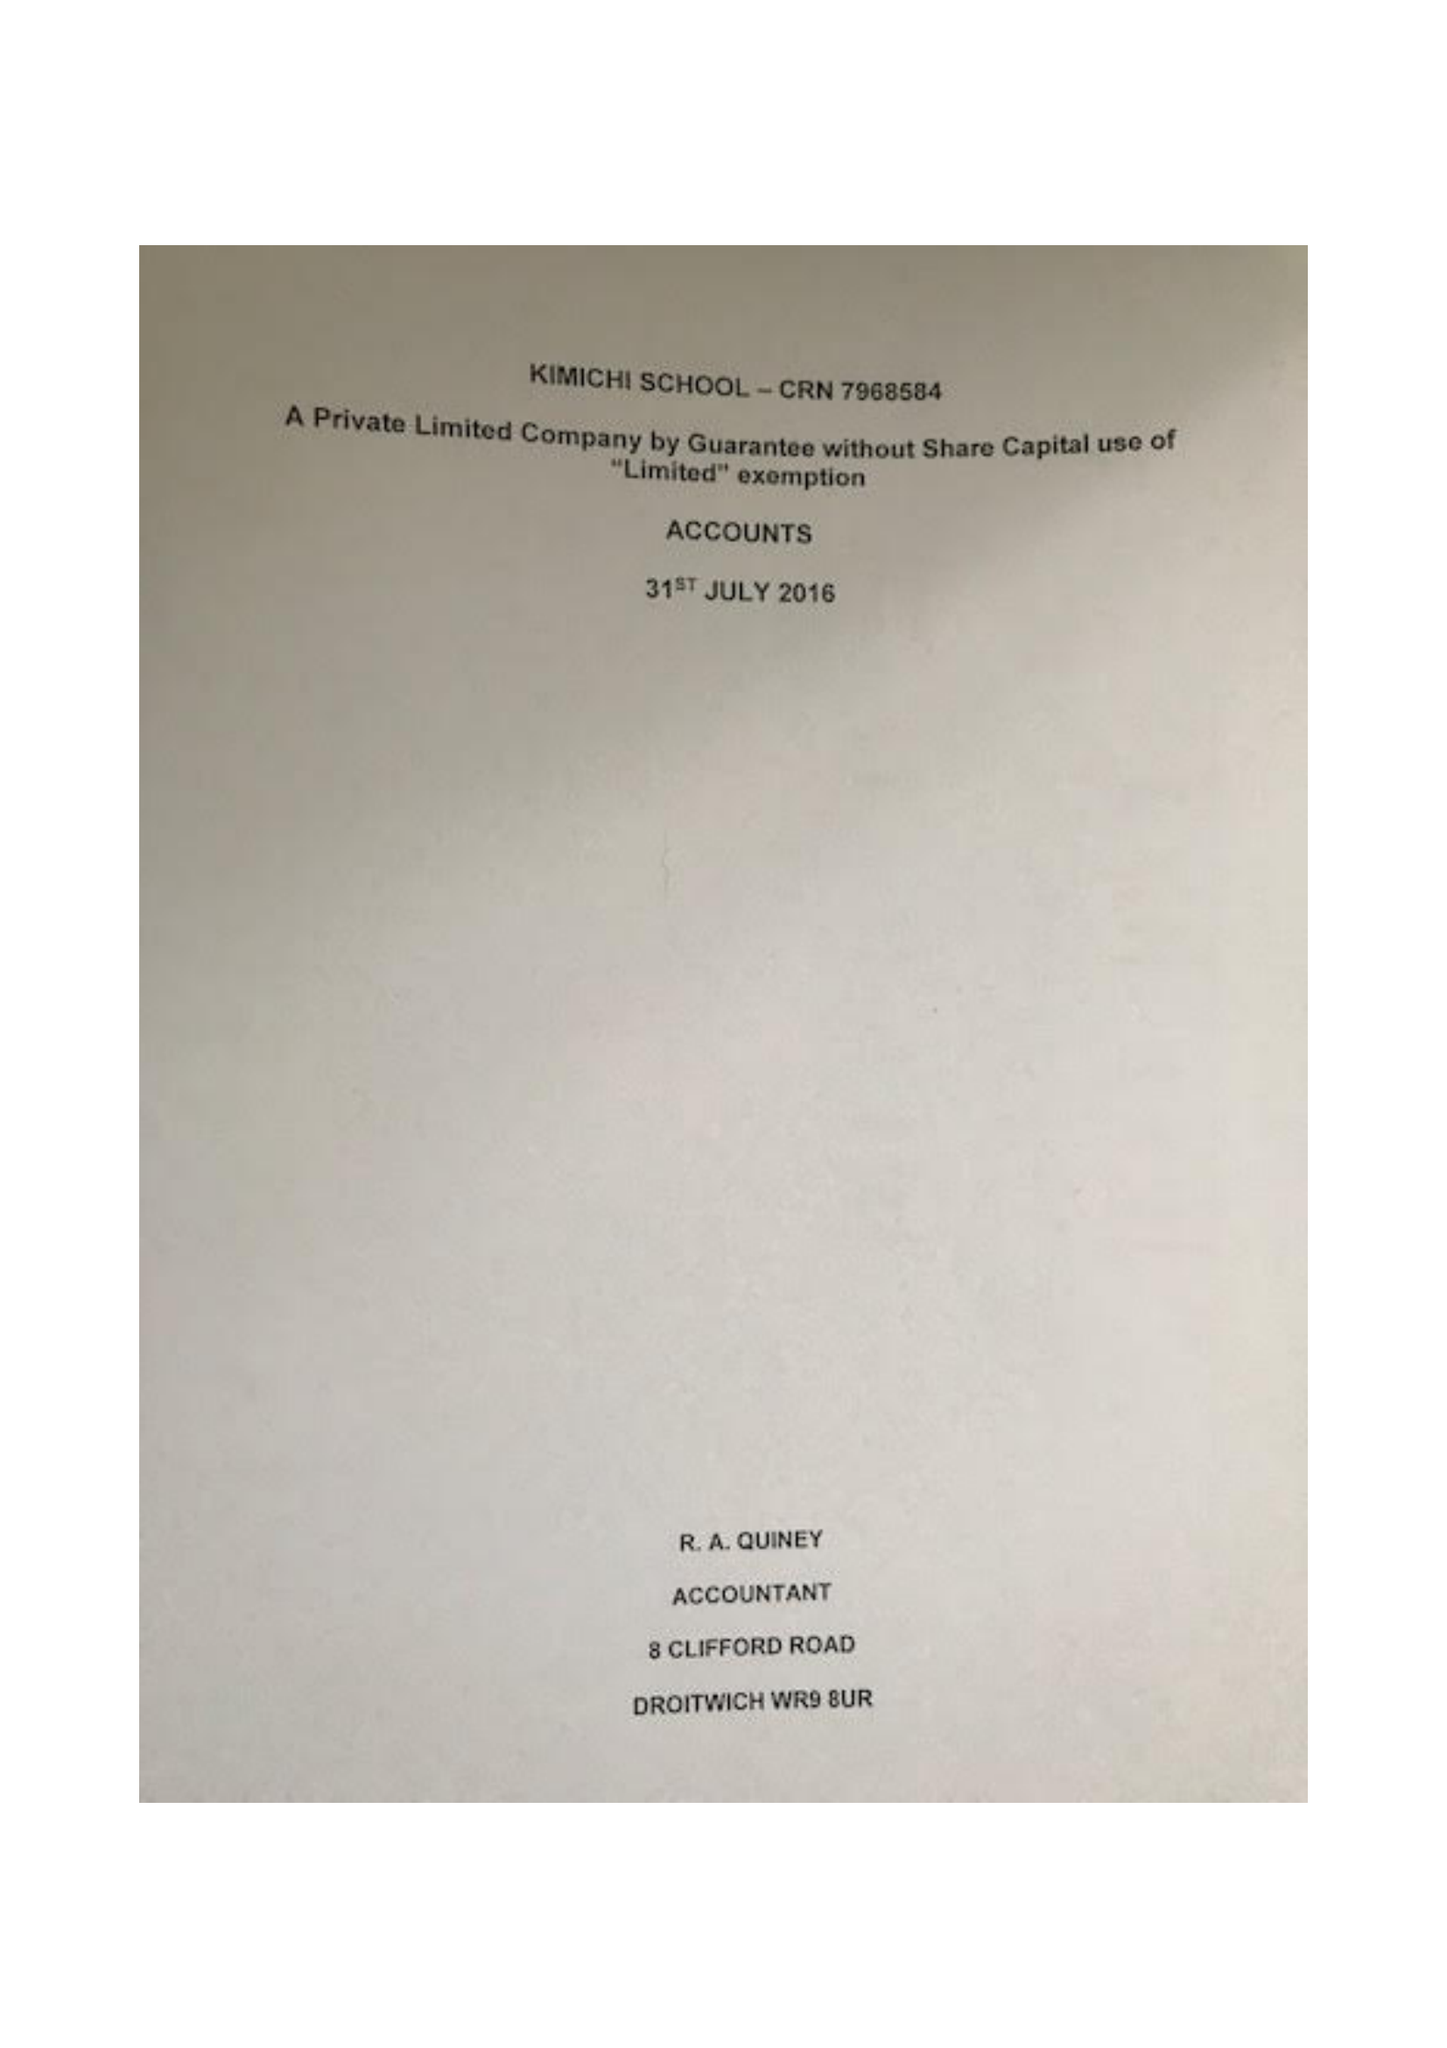What is the value for the address__postcode?
Answer the question using a single word or phrase. B27 6LL 